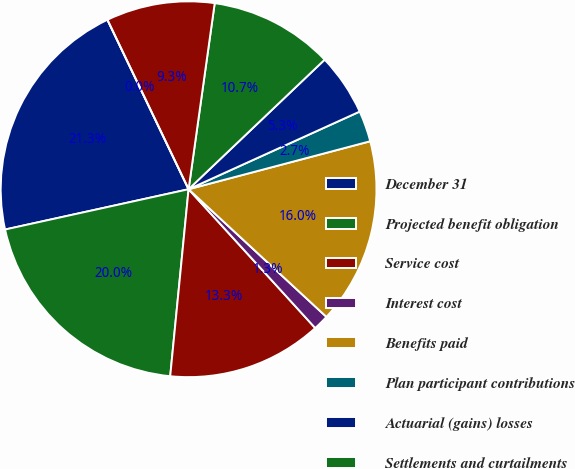Convert chart. <chart><loc_0><loc_0><loc_500><loc_500><pie_chart><fcel>December 31<fcel>Projected benefit obligation<fcel>Service cost<fcel>Interest cost<fcel>Benefits paid<fcel>Plan participant contributions<fcel>Actuarial (gains) losses<fcel>Settlements and curtailments<fcel>Foreign currency effect<fcel>Other<nl><fcel>21.33%<fcel>20.0%<fcel>13.33%<fcel>1.34%<fcel>16.0%<fcel>2.67%<fcel>5.33%<fcel>10.67%<fcel>9.33%<fcel>0.0%<nl></chart> 